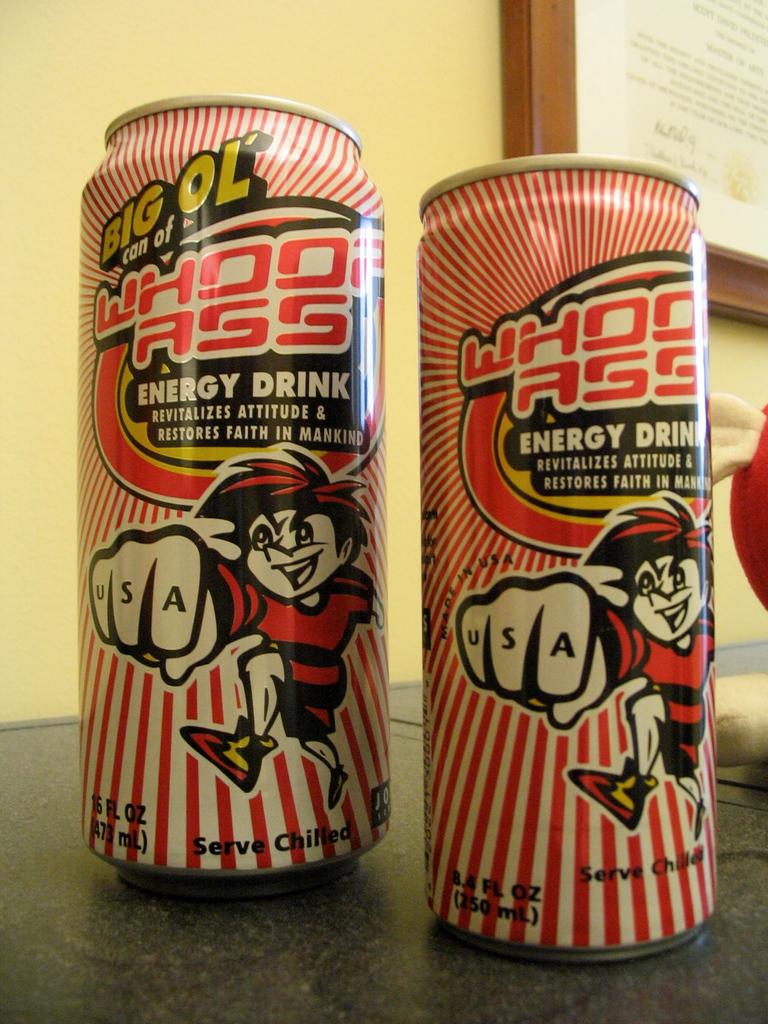What kind of drink is this?
Make the answer very short. Energy drink. 